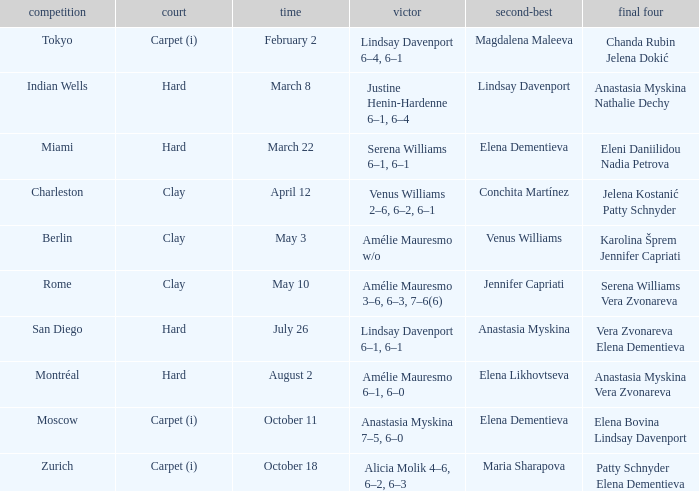Who was the winner of the Miami tournament where Elena Dementieva was a finalist? Serena Williams 6–1, 6–1. 